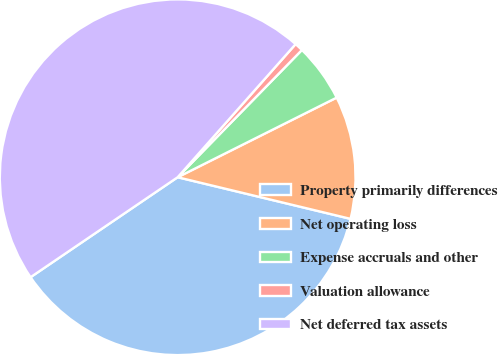Convert chart. <chart><loc_0><loc_0><loc_500><loc_500><pie_chart><fcel>Property primarily differences<fcel>Net operating loss<fcel>Expense accruals and other<fcel>Valuation allowance<fcel>Net deferred tax assets<nl><fcel>36.74%<fcel>11.15%<fcel>5.3%<fcel>0.77%<fcel>46.04%<nl></chart> 